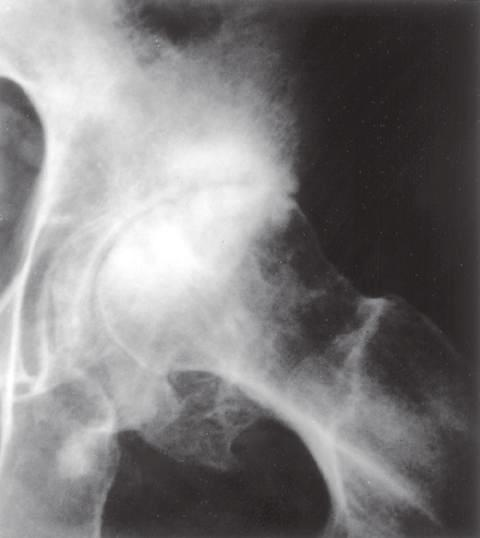s infective endocarditis narrowed?
Answer the question using a single word or phrase. No 